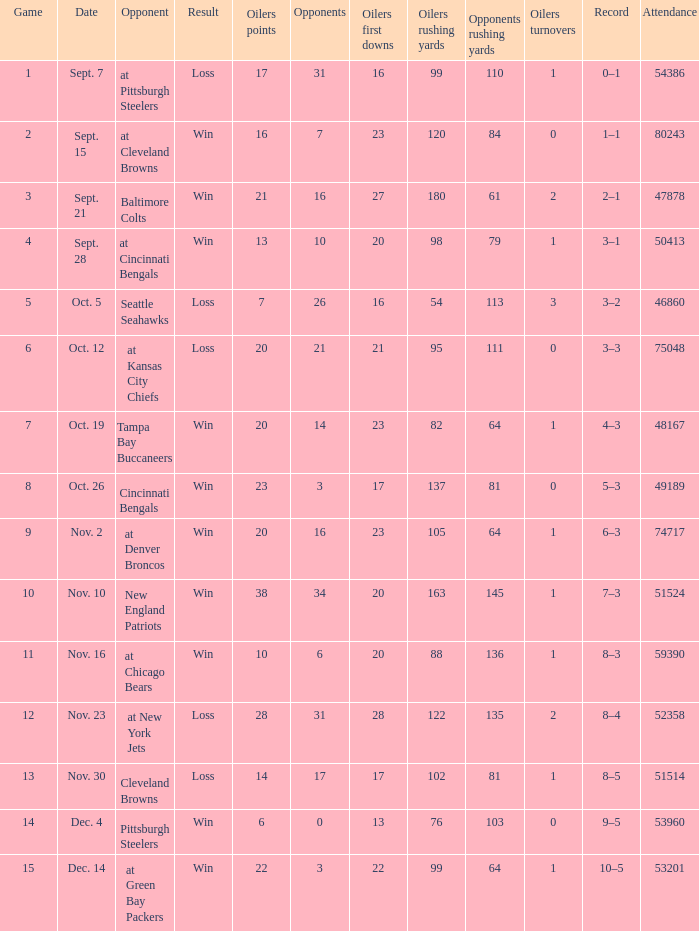Help me parse the entirety of this table. {'header': ['Game', 'Date', 'Opponent', 'Result', 'Oilers points', 'Opponents', 'Oilers first downs', 'Oilers rushing yards', 'Opponents rushing yards', 'Oilers turnovers', 'Record', 'Attendance'], 'rows': [['1', 'Sept. 7', 'at Pittsburgh Steelers', 'Loss', '17', '31', '16', '99', '110', '1', '0–1', '54386'], ['2', 'Sept. 15', 'at Cleveland Browns', 'Win', '16', '7', '23', '120', '84', '0', '1–1', '80243'], ['3', 'Sept. 21', 'Baltimore Colts', 'Win', '21', '16', '27', '180', '61', '2', '2–1', '47878'], ['4', 'Sept. 28', 'at Cincinnati Bengals', 'Win', '13', '10', '20', '98', '79', '1', '3–1', '50413'], ['5', 'Oct. 5', 'Seattle Seahawks', 'Loss', '7', '26', '16', '54', '113', '3', '3–2', '46860'], ['6', 'Oct. 12', 'at Kansas City Chiefs', 'Loss', '20', '21', '21', '95', '111', '0', '3–3', '75048'], ['7', 'Oct. 19', 'Tampa Bay Buccaneers', 'Win', '20', '14', '23', '82', '64', '1', '4–3', '48167'], ['8', 'Oct. 26', 'Cincinnati Bengals', 'Win', '23', '3', '17', '137', '81', '0', '5–3', '49189'], ['9', 'Nov. 2', 'at Denver Broncos', 'Win', '20', '16', '23', '105', '64', '1', '6–3', '74717'], ['10', 'Nov. 10', 'New England Patriots', 'Win', '38', '34', '20', '163', '145', '1', '7–3', '51524'], ['11', 'Nov. 16', 'at Chicago Bears', 'Win', '10', '6', '20', '88', '136', '1', '8–3', '59390'], ['12', 'Nov. 23', 'at New York Jets', 'Loss', '28', '31', '28', '122', '135', '2', '8–4', '52358'], ['13', 'Nov. 30', 'Cleveland Browns', 'Loss', '14', '17', '17', '102', '81', '1', '8–5', '51514'], ['14', 'Dec. 4', 'Pittsburgh Steelers', 'Win', '6', '0', '13', '76', '103', '0', '9–5', '53960'], ['15', 'Dec. 14', 'at Green Bay Packers', 'Win', '22', '3', '22', '99', '64', '1', '10–5', '53201']]} What was the total opponents points for the game were the Oilers scored 21? 16.0. 